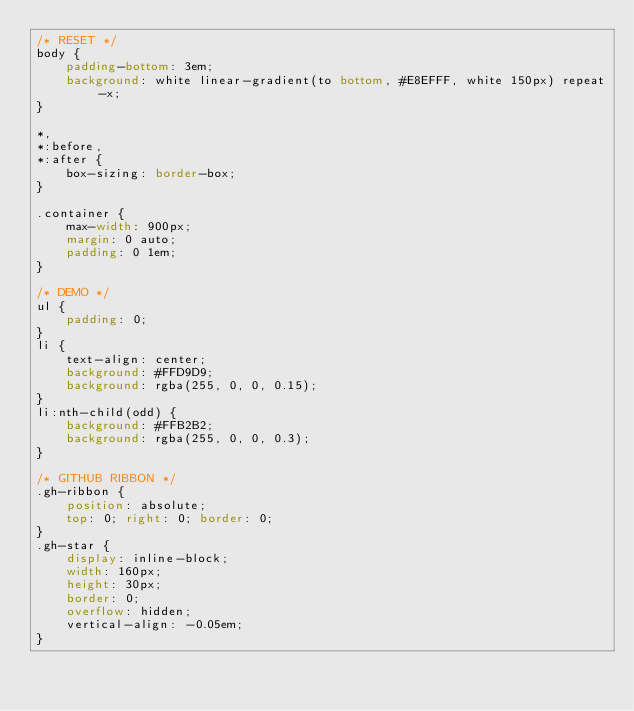<code> <loc_0><loc_0><loc_500><loc_500><_CSS_>/* RESET */
body {
    padding-bottom: 3em;
    background: white linear-gradient(to bottom, #E8EFFF, white 150px) repeat-x;
}

*,
*:before,
*:after {
    box-sizing: border-box;
}

.container {
    max-width: 900px;
    margin: 0 auto;
    padding: 0 1em;
}

/* DEMO */
ul {
    padding: 0;
}
li {
    text-align: center;
    background: #FFD9D9;
    background: rgba(255, 0, 0, 0.15);
}
li:nth-child(odd) {
    background: #FFB2B2;
    background: rgba(255, 0, 0, 0.3);
}

/* GITHUB RIBBON */
.gh-ribbon {
    position: absolute;
    top: 0; right: 0; border: 0;
}
.gh-star {
    display: inline-block;
    width: 160px;
    height: 30px;
    border: 0;
    overflow: hidden;
    vertical-align: -0.05em;
}</code> 